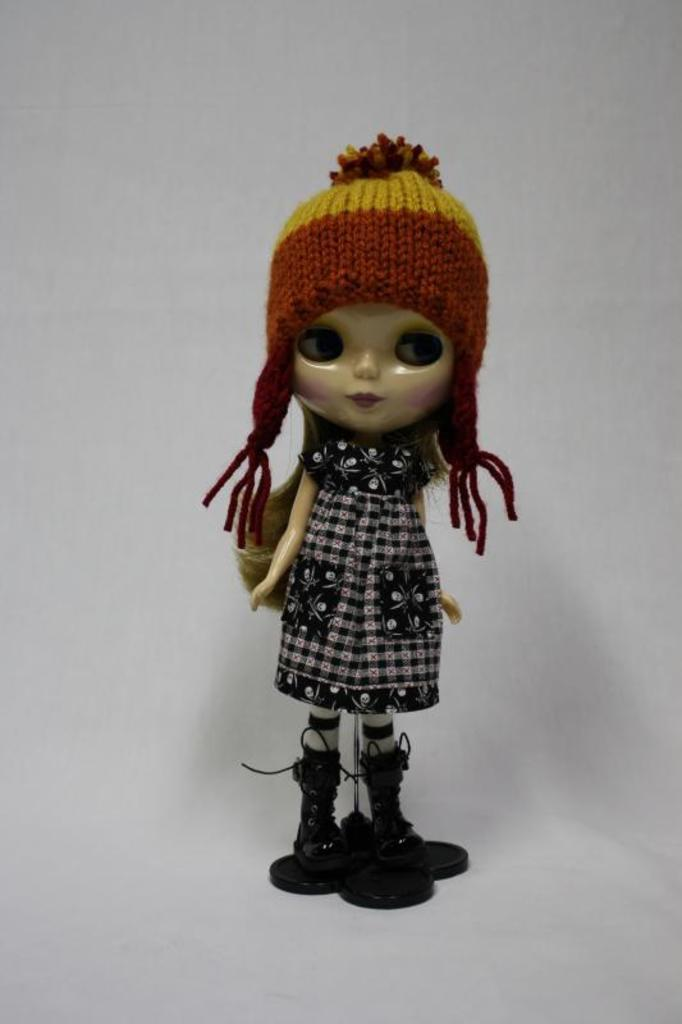What is the main subject of the image? There is a doll in the image. What color is the background of the image? The background of the image is white. What type of board is being used to copy the doll in the image? There is no board or copying activity present in the image; it only features a doll against a white background. 